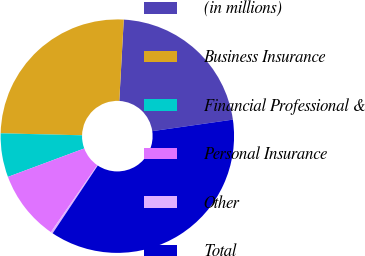Convert chart to OTSL. <chart><loc_0><loc_0><loc_500><loc_500><pie_chart><fcel>(in millions)<fcel>Business Insurance<fcel>Financial Professional &<fcel>Personal Insurance<fcel>Other<fcel>Total<nl><fcel>21.86%<fcel>25.49%<fcel>6.06%<fcel>9.69%<fcel>0.29%<fcel>36.61%<nl></chart> 